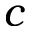<formula> <loc_0><loc_0><loc_500><loc_500>{ c }</formula> 